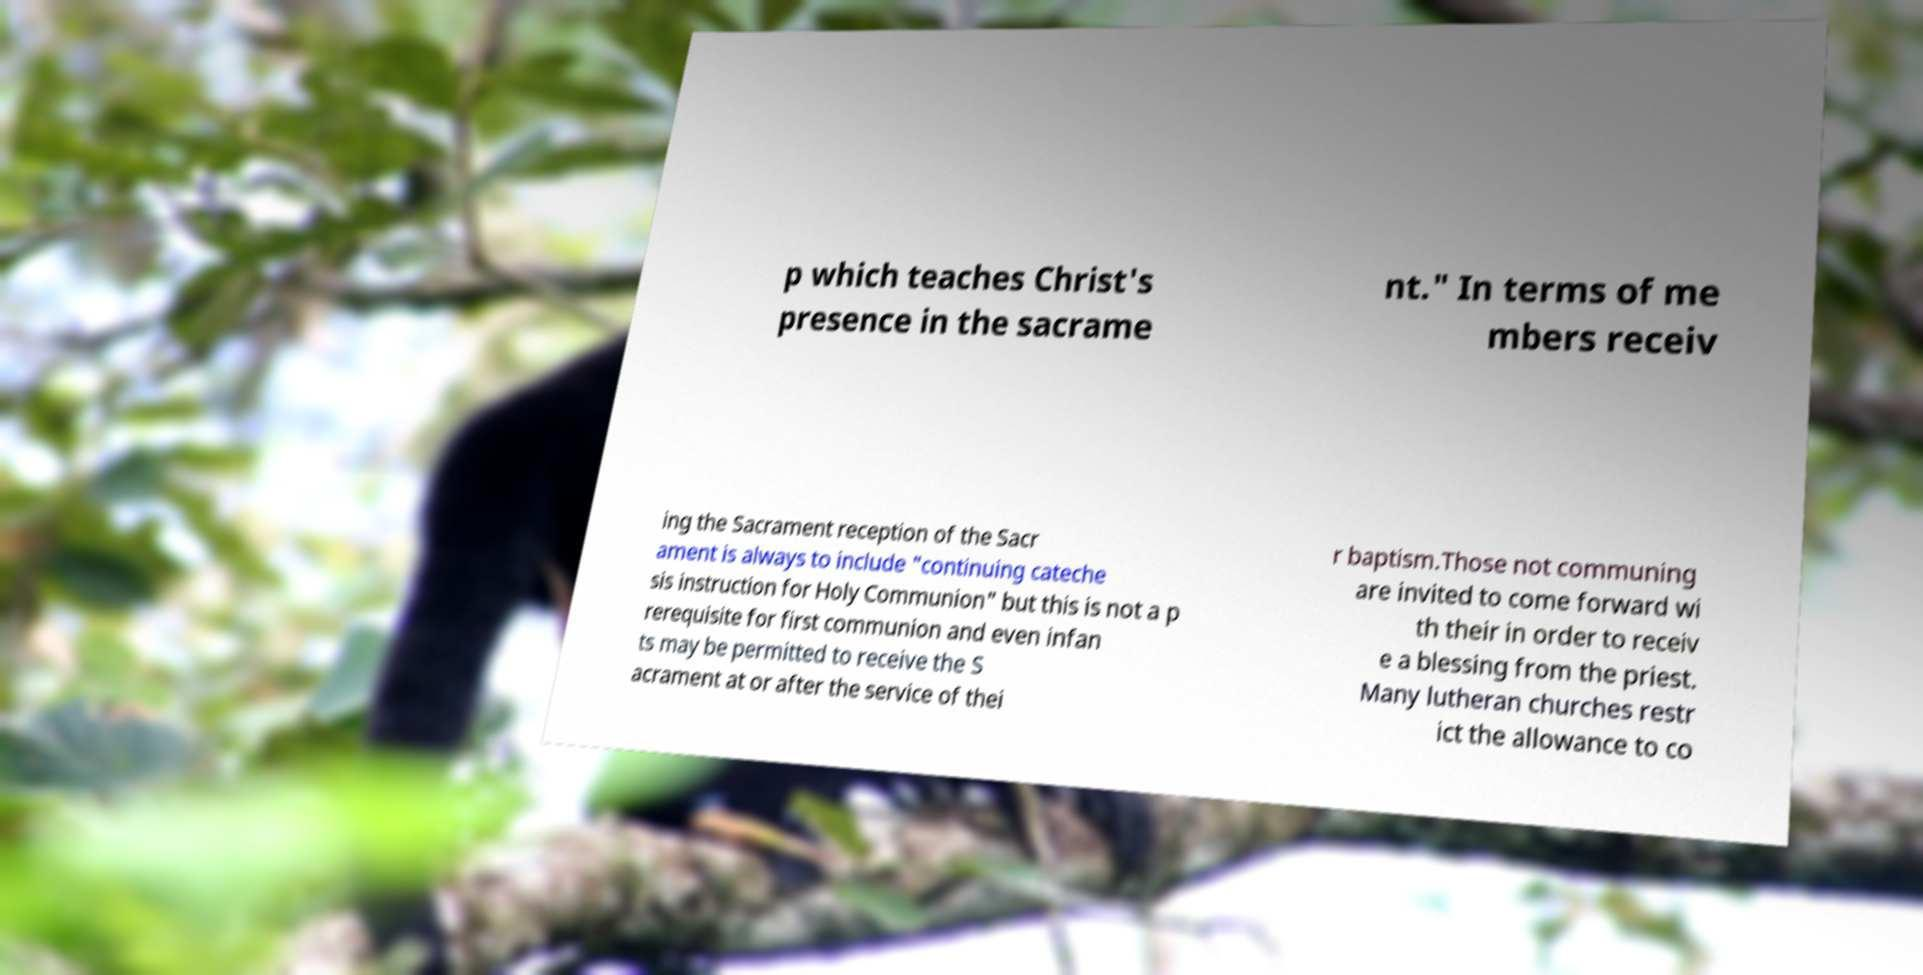What messages or text are displayed in this image? I need them in a readable, typed format. p which teaches Christ's presence in the sacrame nt." In terms of me mbers receiv ing the Sacrament reception of the Sacr ament is always to include "continuing cateche sis instruction for Holy Communion" but this is not a p rerequisite for first communion and even infan ts may be permitted to receive the S acrament at or after the service of thei r baptism.Those not communing are invited to come forward wi th their in order to receiv e a blessing from the priest. Many lutheran churches restr ict the allowance to co 